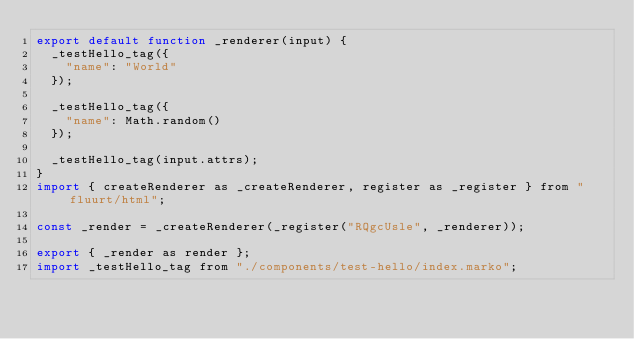<code> <loc_0><loc_0><loc_500><loc_500><_JavaScript_>export default function _renderer(input) {
  _testHello_tag({
    "name": "World"
  });

  _testHello_tag({
    "name": Math.random()
  });

  _testHello_tag(input.attrs);
}
import { createRenderer as _createRenderer, register as _register } from "fluurt/html";

const _render = _createRenderer(_register("RQgcUsle", _renderer));

export { _render as render };
import _testHello_tag from "./components/test-hello/index.marko";</code> 